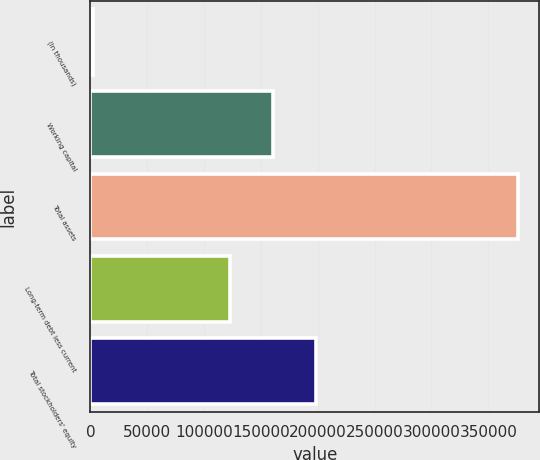Convert chart. <chart><loc_0><loc_0><loc_500><loc_500><bar_chart><fcel>(In thousands)<fcel>Working capital<fcel>Total assets<fcel>Long-term debt less current<fcel>Total stockholders' equity<nl><fcel>2002<fcel>160669<fcel>376191<fcel>123250<fcel>198088<nl></chart> 